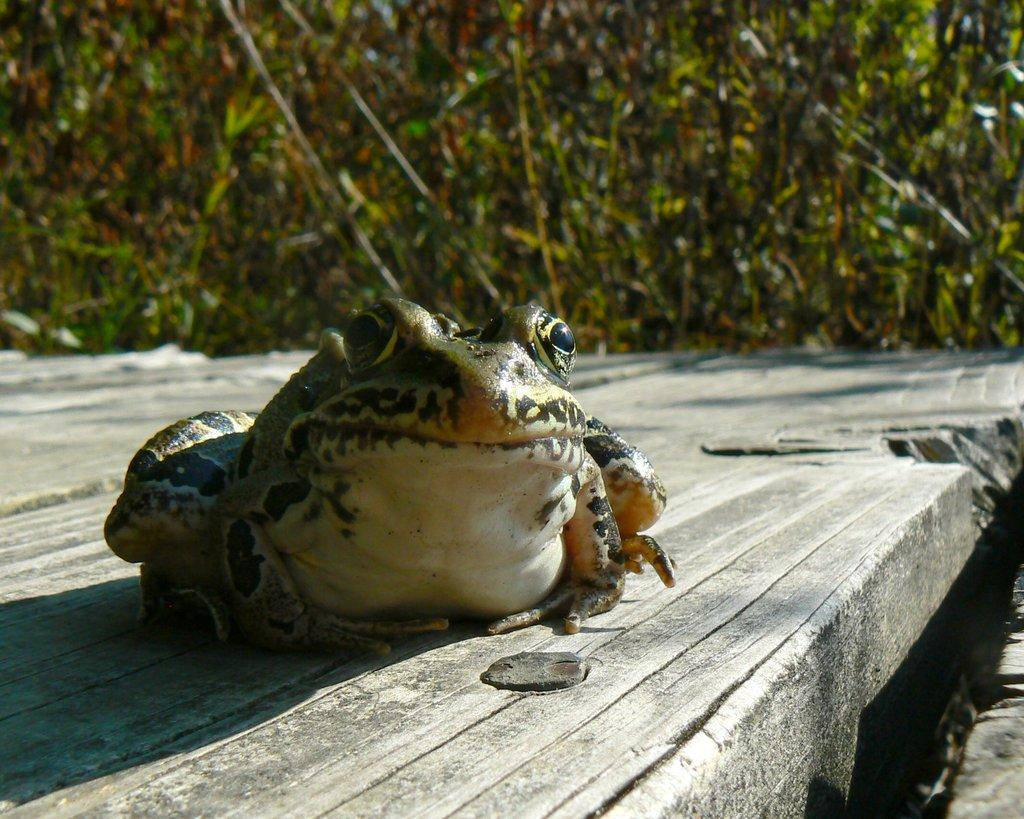What animal is present in the image? There is a frog in the image. What is the frog doing in the image? The frog is sitting on an object. What can be seen in the background of the image? There are trees in the background of the image. What type of pies can be seen in the image? There are no pies present in the image; it features a frog sitting on an object with trees in the background. What kind of bait is the frog using to catch fish in the image? There is no indication in the image that the frog is trying to catch fish or using any bait. 